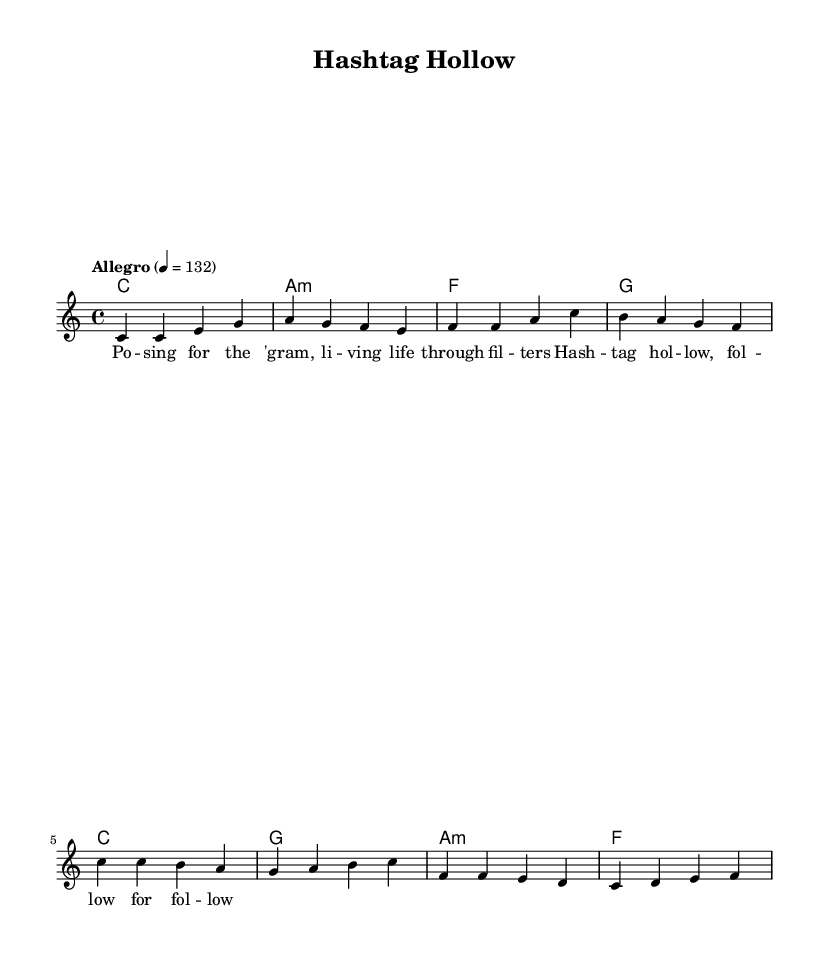What is the title of this piece? The title is indicated under the header section of the sheet music as "Hashtag Hollow."
Answer: Hashtag Hollow What is the key signature of this music? The key is C major, which is displayed as having no sharps or flats in the key signature.
Answer: C major What is the time signature of the piece? The time signature appears in the global settings and is indicated as 4/4, which means there are four beats per measure.
Answer: 4/4 What is the tempo marking for this piece? The tempo marking is indicated as "Allegro," with a note value of 132 beats per minute, meaning it should be played fast.
Answer: Allegro How many measures are in the verse section? The verse section comprises four measures, visually counted from the music notation provided.
Answer: Four Which chord follows the A minor chord in the chorus? After the A minor chord, the next chord in the chorus is F major, according to the chord progression provided.
Answer: F What emotion or theme does the title suggest about the song? The title "Hashtag Hollow" suggests a satirical view of the superficiality of social media culture, indicating a theme of emptiness among digital fame.
Answer: Superficiality 